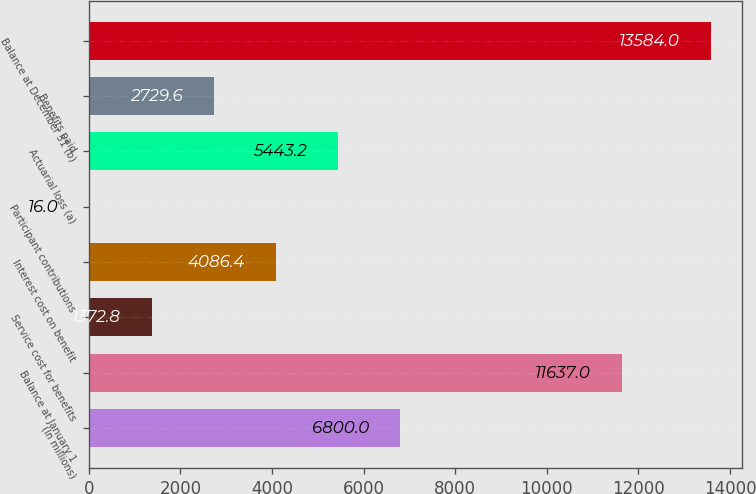Convert chart. <chart><loc_0><loc_0><loc_500><loc_500><bar_chart><fcel>(In millions)<fcel>Balance at January 1<fcel>Service cost for benefits<fcel>Interest cost on benefit<fcel>Participant contributions<fcel>Actuarial loss (a)<fcel>Benefits paid<fcel>Balance at December 31 (b)<nl><fcel>6800<fcel>11637<fcel>1372.8<fcel>4086.4<fcel>16<fcel>5443.2<fcel>2729.6<fcel>13584<nl></chart> 